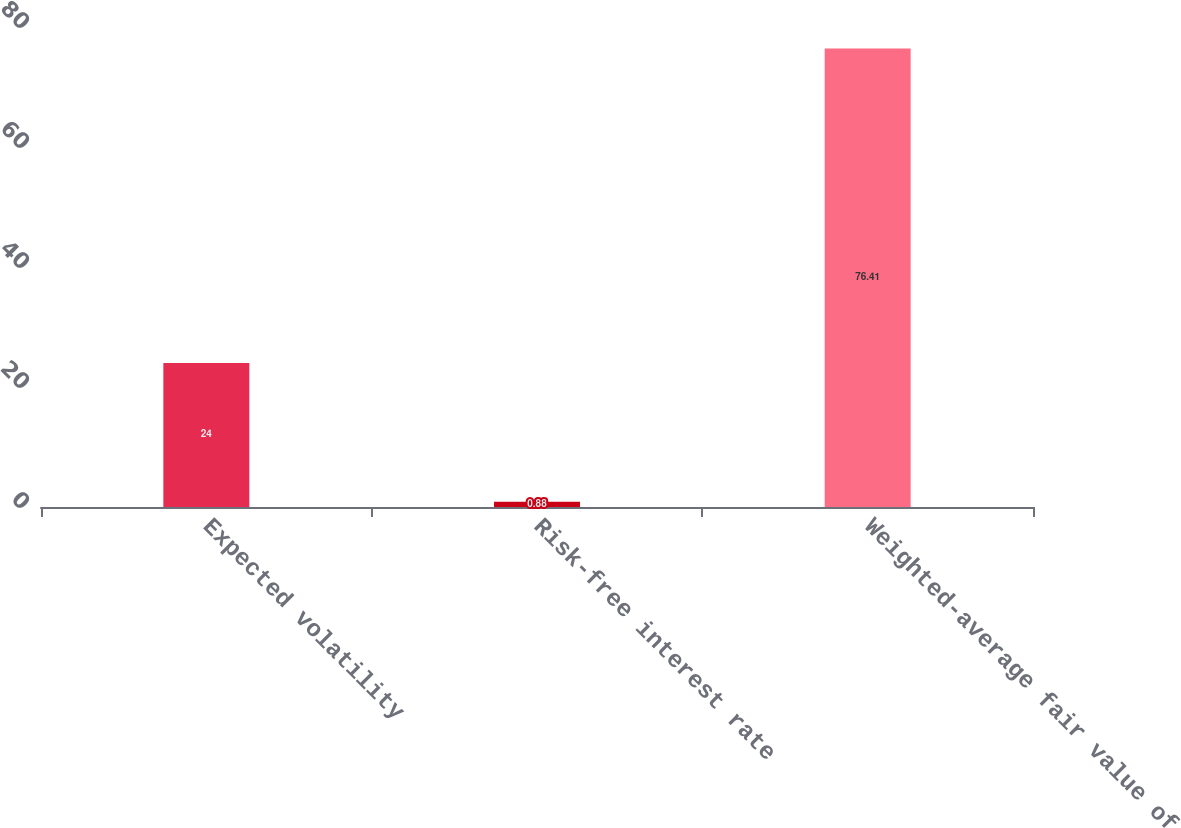Convert chart to OTSL. <chart><loc_0><loc_0><loc_500><loc_500><bar_chart><fcel>Expected volatility<fcel>Risk-free interest rate<fcel>Weighted-average fair value of<nl><fcel>24<fcel>0.88<fcel>76.41<nl></chart> 